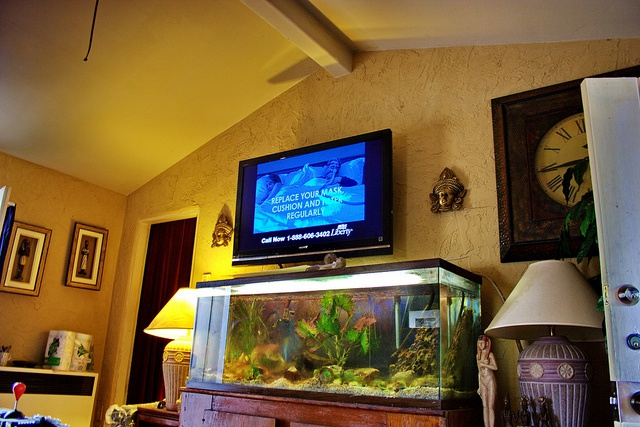Describe the objects in this image and their specific colors. I can see tv in black, blue, lightblue, and navy tones and clock in black, olive, and maroon tones in this image. 